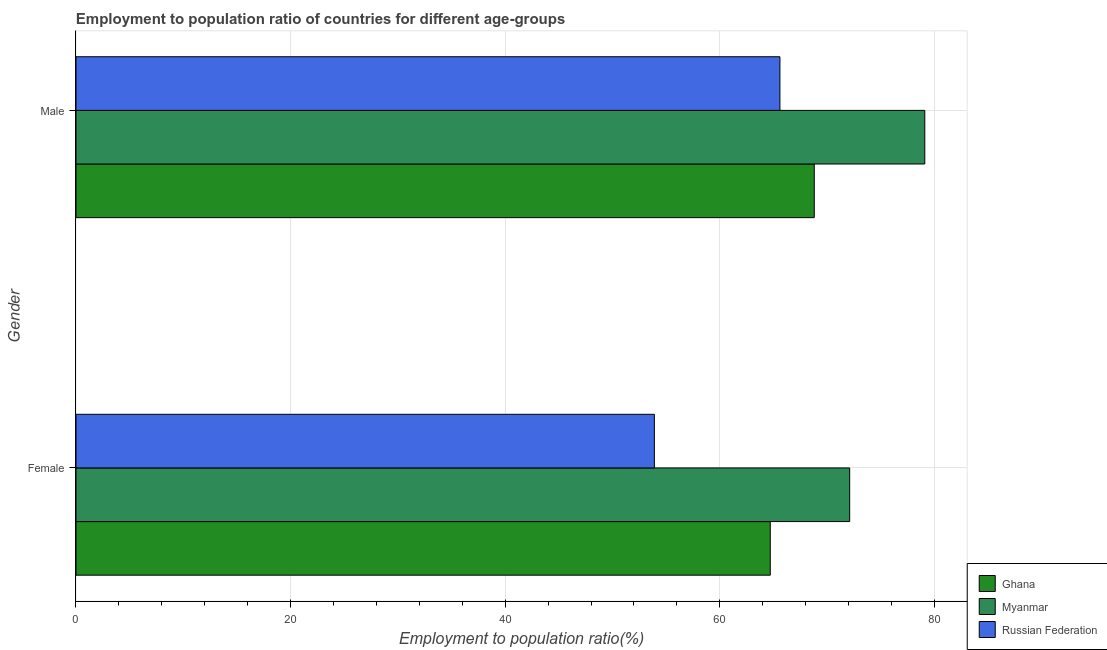How many groups of bars are there?
Make the answer very short. 2. Are the number of bars on each tick of the Y-axis equal?
Offer a terse response. Yes. How many bars are there on the 2nd tick from the top?
Your response must be concise. 3. How many bars are there on the 1st tick from the bottom?
Offer a terse response. 3. What is the employment to population ratio(male) in Myanmar?
Your response must be concise. 79.1. Across all countries, what is the maximum employment to population ratio(female)?
Your answer should be compact. 72.1. Across all countries, what is the minimum employment to population ratio(male)?
Keep it short and to the point. 65.6. In which country was the employment to population ratio(male) maximum?
Provide a short and direct response. Myanmar. In which country was the employment to population ratio(male) minimum?
Offer a very short reply. Russian Federation. What is the total employment to population ratio(female) in the graph?
Provide a succinct answer. 190.7. What is the difference between the employment to population ratio(female) in Russian Federation and that in Myanmar?
Ensure brevity in your answer.  -18.2. What is the difference between the employment to population ratio(female) in Russian Federation and the employment to population ratio(male) in Ghana?
Offer a terse response. -14.9. What is the average employment to population ratio(male) per country?
Offer a terse response. 71.17. What is the difference between the employment to population ratio(female) and employment to population ratio(male) in Russian Federation?
Offer a very short reply. -11.7. What is the ratio of the employment to population ratio(female) in Ghana to that in Russian Federation?
Provide a succinct answer. 1.2. Is the employment to population ratio(female) in Russian Federation less than that in Ghana?
Provide a short and direct response. Yes. What does the 2nd bar from the top in Female represents?
Ensure brevity in your answer.  Myanmar. Are all the bars in the graph horizontal?
Ensure brevity in your answer.  Yes. How many countries are there in the graph?
Give a very brief answer. 3. What is the difference between two consecutive major ticks on the X-axis?
Give a very brief answer. 20. Are the values on the major ticks of X-axis written in scientific E-notation?
Make the answer very short. No. Where does the legend appear in the graph?
Give a very brief answer. Bottom right. How are the legend labels stacked?
Make the answer very short. Vertical. What is the title of the graph?
Keep it short and to the point. Employment to population ratio of countries for different age-groups. Does "Thailand" appear as one of the legend labels in the graph?
Provide a succinct answer. No. What is the label or title of the X-axis?
Give a very brief answer. Employment to population ratio(%). What is the label or title of the Y-axis?
Provide a short and direct response. Gender. What is the Employment to population ratio(%) of Ghana in Female?
Your answer should be very brief. 64.7. What is the Employment to population ratio(%) of Myanmar in Female?
Your answer should be compact. 72.1. What is the Employment to population ratio(%) in Russian Federation in Female?
Ensure brevity in your answer.  53.9. What is the Employment to population ratio(%) in Ghana in Male?
Offer a very short reply. 68.8. What is the Employment to population ratio(%) in Myanmar in Male?
Your response must be concise. 79.1. What is the Employment to population ratio(%) of Russian Federation in Male?
Give a very brief answer. 65.6. Across all Gender, what is the maximum Employment to population ratio(%) in Ghana?
Provide a short and direct response. 68.8. Across all Gender, what is the maximum Employment to population ratio(%) of Myanmar?
Provide a short and direct response. 79.1. Across all Gender, what is the maximum Employment to population ratio(%) of Russian Federation?
Make the answer very short. 65.6. Across all Gender, what is the minimum Employment to population ratio(%) of Ghana?
Offer a terse response. 64.7. Across all Gender, what is the minimum Employment to population ratio(%) in Myanmar?
Provide a succinct answer. 72.1. Across all Gender, what is the minimum Employment to population ratio(%) of Russian Federation?
Your answer should be very brief. 53.9. What is the total Employment to population ratio(%) of Ghana in the graph?
Provide a succinct answer. 133.5. What is the total Employment to population ratio(%) in Myanmar in the graph?
Offer a very short reply. 151.2. What is the total Employment to population ratio(%) of Russian Federation in the graph?
Offer a terse response. 119.5. What is the difference between the Employment to population ratio(%) in Ghana in Female and the Employment to population ratio(%) in Myanmar in Male?
Keep it short and to the point. -14.4. What is the difference between the Employment to population ratio(%) of Ghana in Female and the Employment to population ratio(%) of Russian Federation in Male?
Ensure brevity in your answer.  -0.9. What is the difference between the Employment to population ratio(%) in Myanmar in Female and the Employment to population ratio(%) in Russian Federation in Male?
Your answer should be compact. 6.5. What is the average Employment to population ratio(%) in Ghana per Gender?
Make the answer very short. 66.75. What is the average Employment to population ratio(%) of Myanmar per Gender?
Provide a succinct answer. 75.6. What is the average Employment to population ratio(%) of Russian Federation per Gender?
Offer a terse response. 59.75. What is the difference between the Employment to population ratio(%) in Ghana and Employment to population ratio(%) in Myanmar in Female?
Provide a short and direct response. -7.4. What is the difference between the Employment to population ratio(%) in Ghana and Employment to population ratio(%) in Russian Federation in Female?
Give a very brief answer. 10.8. What is the difference between the Employment to population ratio(%) in Ghana and Employment to population ratio(%) in Myanmar in Male?
Your answer should be very brief. -10.3. What is the difference between the Employment to population ratio(%) in Ghana and Employment to population ratio(%) in Russian Federation in Male?
Offer a very short reply. 3.2. What is the difference between the Employment to population ratio(%) of Myanmar and Employment to population ratio(%) of Russian Federation in Male?
Ensure brevity in your answer.  13.5. What is the ratio of the Employment to population ratio(%) in Ghana in Female to that in Male?
Your answer should be very brief. 0.94. What is the ratio of the Employment to population ratio(%) of Myanmar in Female to that in Male?
Provide a short and direct response. 0.91. What is the ratio of the Employment to population ratio(%) of Russian Federation in Female to that in Male?
Provide a short and direct response. 0.82. What is the difference between the highest and the second highest Employment to population ratio(%) in Ghana?
Offer a very short reply. 4.1. What is the difference between the highest and the second highest Employment to population ratio(%) of Myanmar?
Your answer should be compact. 7. What is the difference between the highest and the lowest Employment to population ratio(%) in Myanmar?
Your answer should be compact. 7. 